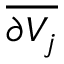Convert formula to latex. <formula><loc_0><loc_0><loc_500><loc_500>\overline { { \partial V _ { j } } }</formula> 